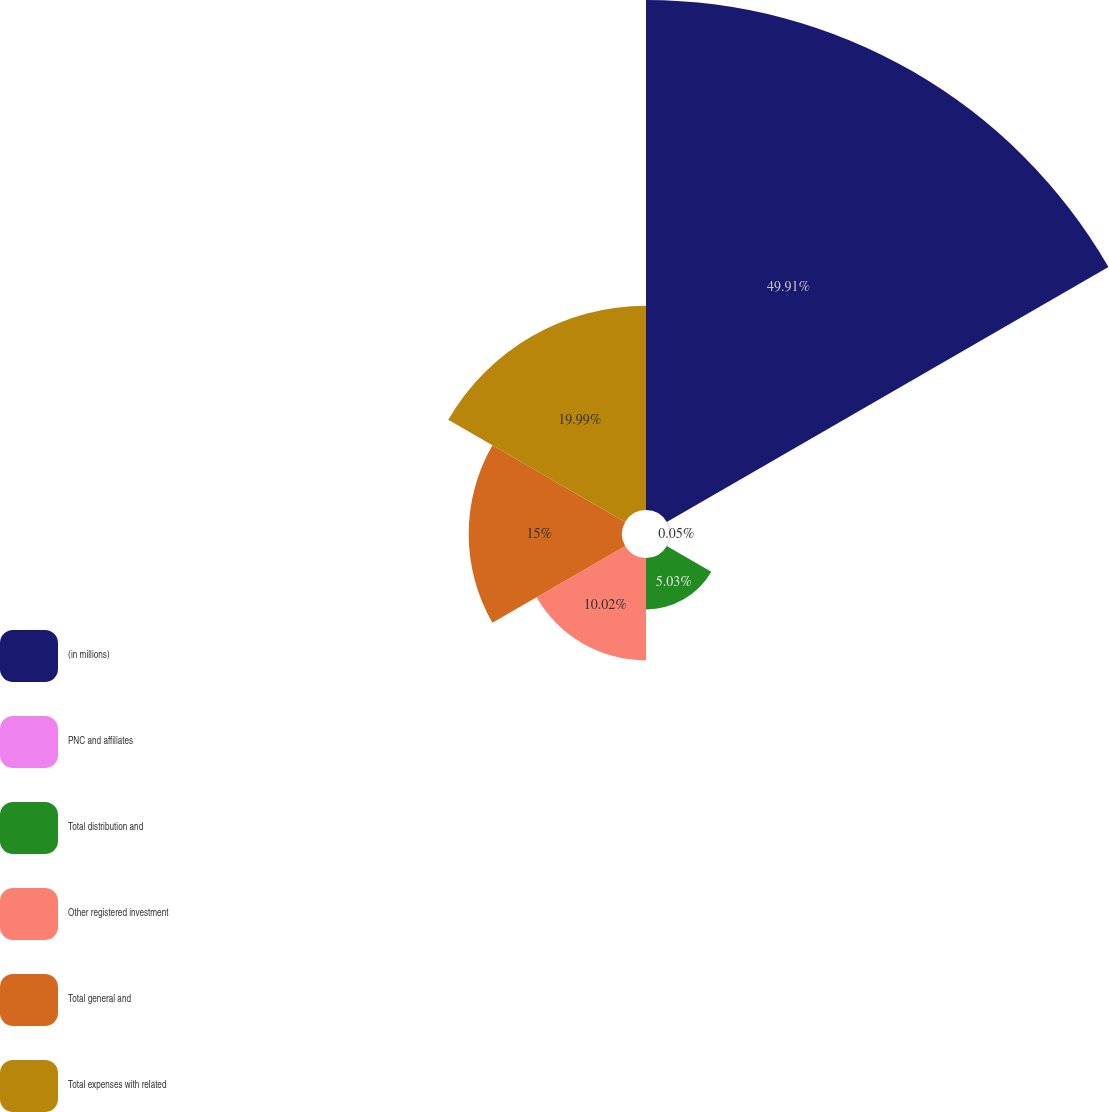<chart> <loc_0><loc_0><loc_500><loc_500><pie_chart><fcel>(in millions)<fcel>PNC and affiliates<fcel>Total distribution and<fcel>Other registered investment<fcel>Total general and<fcel>Total expenses with related<nl><fcel>49.9%<fcel>0.05%<fcel>5.03%<fcel>10.02%<fcel>15.0%<fcel>19.99%<nl></chart> 